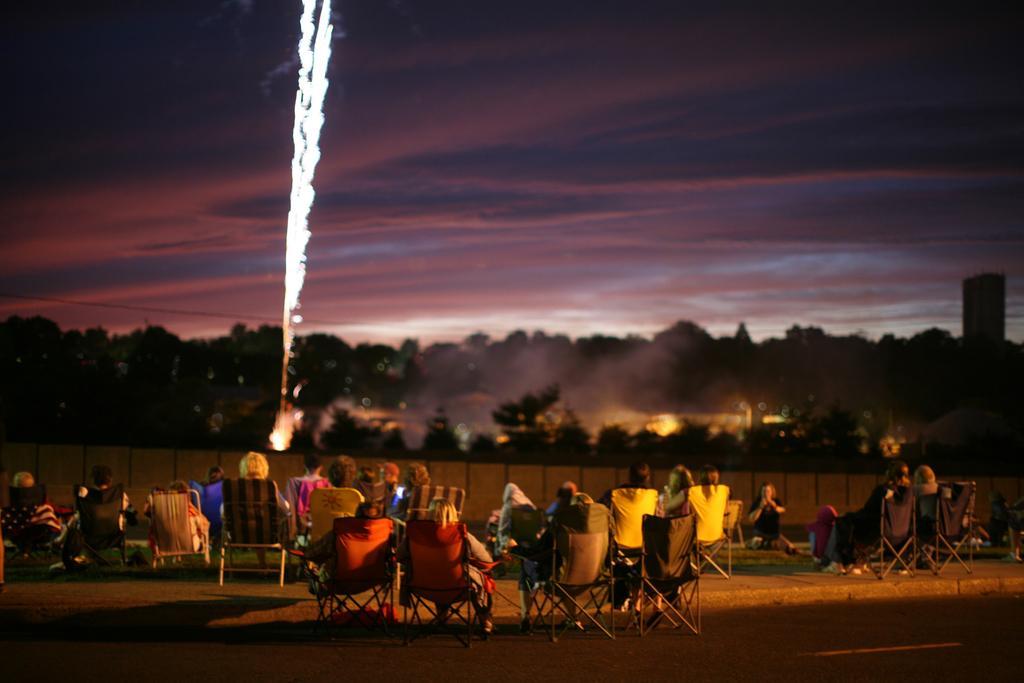Describe this image in one or two sentences. At the bottom of the image few people are sitting. In front of them we can see some trees and fire works. At the top of the image we can see some clouds in the sky. 